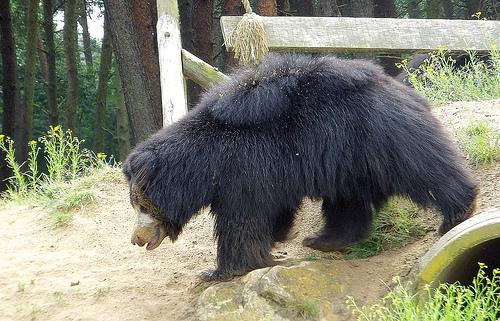Question: when was the photo taken?
Choices:
A. Daytime.
B. Noon.
C. At 10:00.
D. In the morning.
Answer with the letter. Answer: A Question: what type of animal is shown?
Choices:
A. Horse.
B. Lizard.
C. Cat.
D. Bear.
Answer with the letter. Answer: D Question: what type of fence is shown?
Choices:
A. Wood.
B. Chain link.
C. Metal.
D. Large wooden post.
Answer with the letter. Answer: A Question: how many of the bear's feet can be seen?
Choices:
A. Two.
B. One.
C. Four.
D. Three.
Answer with the letter. Answer: D Question: what is in the background?
Choices:
A. Buildings.
B. Ocean.
C. Trees.
D. Mountains.
Answer with the letter. Answer: C Question: what color are the flowers?
Choices:
A. Yellow.
B. Red.
C. White.
D. Blue.
Answer with the letter. Answer: A Question: what is under the bears front paw?
Choices:
A. Water.
B. Fish.
C. Rock.
D. Grass.
Answer with the letter. Answer: C 